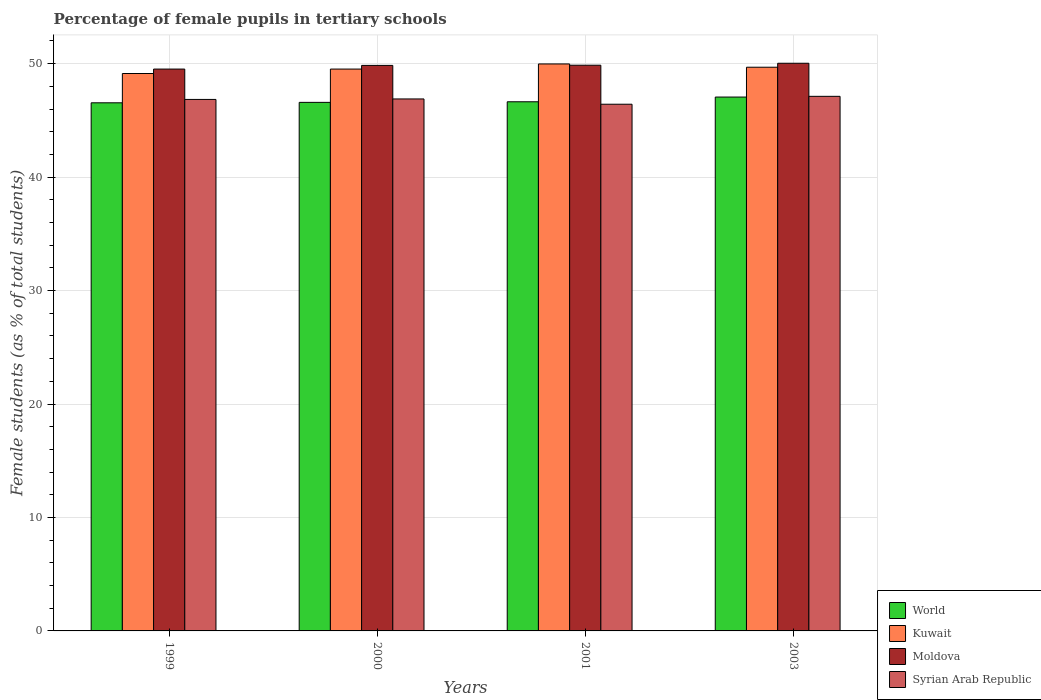How many different coloured bars are there?
Your answer should be very brief. 4. How many groups of bars are there?
Provide a short and direct response. 4. Are the number of bars per tick equal to the number of legend labels?
Give a very brief answer. Yes. What is the percentage of female pupils in tertiary schools in World in 2001?
Your answer should be very brief. 46.64. Across all years, what is the maximum percentage of female pupils in tertiary schools in Syrian Arab Republic?
Provide a succinct answer. 47.12. Across all years, what is the minimum percentage of female pupils in tertiary schools in Moldova?
Provide a short and direct response. 49.52. In which year was the percentage of female pupils in tertiary schools in Syrian Arab Republic minimum?
Provide a short and direct response. 2001. What is the total percentage of female pupils in tertiary schools in Syrian Arab Republic in the graph?
Make the answer very short. 187.27. What is the difference between the percentage of female pupils in tertiary schools in Syrian Arab Republic in 1999 and that in 2001?
Offer a terse response. 0.42. What is the difference between the percentage of female pupils in tertiary schools in Moldova in 2000 and the percentage of female pupils in tertiary schools in Syrian Arab Republic in 2003?
Keep it short and to the point. 2.73. What is the average percentage of female pupils in tertiary schools in Syrian Arab Republic per year?
Provide a succinct answer. 46.82. In the year 2000, what is the difference between the percentage of female pupils in tertiary schools in Syrian Arab Republic and percentage of female pupils in tertiary schools in Moldova?
Ensure brevity in your answer.  -2.96. In how many years, is the percentage of female pupils in tertiary schools in World greater than 34 %?
Give a very brief answer. 4. What is the ratio of the percentage of female pupils in tertiary schools in Syrian Arab Republic in 1999 to that in 2003?
Your response must be concise. 0.99. Is the percentage of female pupils in tertiary schools in Moldova in 2000 less than that in 2003?
Your response must be concise. Yes. Is the difference between the percentage of female pupils in tertiary schools in Syrian Arab Republic in 2000 and 2001 greater than the difference between the percentage of female pupils in tertiary schools in Moldova in 2000 and 2001?
Offer a terse response. Yes. What is the difference between the highest and the second highest percentage of female pupils in tertiary schools in World?
Your answer should be very brief. 0.42. What is the difference between the highest and the lowest percentage of female pupils in tertiary schools in Syrian Arab Republic?
Offer a terse response. 0.7. In how many years, is the percentage of female pupils in tertiary schools in Moldova greater than the average percentage of female pupils in tertiary schools in Moldova taken over all years?
Offer a terse response. 3. What does the 3rd bar from the left in 1999 represents?
Your answer should be compact. Moldova. What does the 3rd bar from the right in 2000 represents?
Offer a very short reply. Kuwait. Is it the case that in every year, the sum of the percentage of female pupils in tertiary schools in Kuwait and percentage of female pupils in tertiary schools in Moldova is greater than the percentage of female pupils in tertiary schools in Syrian Arab Republic?
Provide a short and direct response. Yes. Are all the bars in the graph horizontal?
Give a very brief answer. No. What is the difference between two consecutive major ticks on the Y-axis?
Keep it short and to the point. 10. Are the values on the major ticks of Y-axis written in scientific E-notation?
Provide a succinct answer. No. Does the graph contain any zero values?
Provide a short and direct response. No. Does the graph contain grids?
Provide a short and direct response. Yes. Where does the legend appear in the graph?
Provide a succinct answer. Bottom right. How are the legend labels stacked?
Provide a short and direct response. Vertical. What is the title of the graph?
Your response must be concise. Percentage of female pupils in tertiary schools. Does "Aruba" appear as one of the legend labels in the graph?
Give a very brief answer. No. What is the label or title of the X-axis?
Provide a short and direct response. Years. What is the label or title of the Y-axis?
Your response must be concise. Female students (as % of total students). What is the Female students (as % of total students) of World in 1999?
Keep it short and to the point. 46.55. What is the Female students (as % of total students) of Kuwait in 1999?
Your answer should be compact. 49.13. What is the Female students (as % of total students) in Moldova in 1999?
Your response must be concise. 49.52. What is the Female students (as % of total students) of Syrian Arab Republic in 1999?
Provide a succinct answer. 46.84. What is the Female students (as % of total students) of World in 2000?
Give a very brief answer. 46.59. What is the Female students (as % of total students) in Kuwait in 2000?
Provide a succinct answer. 49.52. What is the Female students (as % of total students) of Moldova in 2000?
Your response must be concise. 49.84. What is the Female students (as % of total students) of Syrian Arab Republic in 2000?
Your response must be concise. 46.89. What is the Female students (as % of total students) in World in 2001?
Your answer should be very brief. 46.64. What is the Female students (as % of total students) of Kuwait in 2001?
Provide a succinct answer. 49.97. What is the Female students (as % of total students) in Moldova in 2001?
Keep it short and to the point. 49.86. What is the Female students (as % of total students) of Syrian Arab Republic in 2001?
Your answer should be compact. 46.42. What is the Female students (as % of total students) of World in 2003?
Make the answer very short. 47.05. What is the Female students (as % of total students) of Kuwait in 2003?
Ensure brevity in your answer.  49.68. What is the Female students (as % of total students) of Moldova in 2003?
Keep it short and to the point. 50.03. What is the Female students (as % of total students) in Syrian Arab Republic in 2003?
Provide a succinct answer. 47.12. Across all years, what is the maximum Female students (as % of total students) of World?
Offer a terse response. 47.05. Across all years, what is the maximum Female students (as % of total students) of Kuwait?
Keep it short and to the point. 49.97. Across all years, what is the maximum Female students (as % of total students) of Moldova?
Your response must be concise. 50.03. Across all years, what is the maximum Female students (as % of total students) in Syrian Arab Republic?
Ensure brevity in your answer.  47.12. Across all years, what is the minimum Female students (as % of total students) in World?
Provide a succinct answer. 46.55. Across all years, what is the minimum Female students (as % of total students) of Kuwait?
Your answer should be very brief. 49.13. Across all years, what is the minimum Female students (as % of total students) of Moldova?
Provide a short and direct response. 49.52. Across all years, what is the minimum Female students (as % of total students) in Syrian Arab Republic?
Ensure brevity in your answer.  46.42. What is the total Female students (as % of total students) in World in the graph?
Provide a succinct answer. 186.82. What is the total Female students (as % of total students) in Kuwait in the graph?
Offer a terse response. 198.31. What is the total Female students (as % of total students) in Moldova in the graph?
Your answer should be compact. 199.26. What is the total Female students (as % of total students) of Syrian Arab Republic in the graph?
Your response must be concise. 187.27. What is the difference between the Female students (as % of total students) of World in 1999 and that in 2000?
Make the answer very short. -0.04. What is the difference between the Female students (as % of total students) of Kuwait in 1999 and that in 2000?
Provide a succinct answer. -0.39. What is the difference between the Female students (as % of total students) of Moldova in 1999 and that in 2000?
Provide a succinct answer. -0.32. What is the difference between the Female students (as % of total students) in Syrian Arab Republic in 1999 and that in 2000?
Provide a short and direct response. -0.04. What is the difference between the Female students (as % of total students) of World in 1999 and that in 2001?
Offer a terse response. -0.09. What is the difference between the Female students (as % of total students) of Kuwait in 1999 and that in 2001?
Your answer should be compact. -0.84. What is the difference between the Female students (as % of total students) of Moldova in 1999 and that in 2001?
Provide a succinct answer. -0.34. What is the difference between the Female students (as % of total students) of Syrian Arab Republic in 1999 and that in 2001?
Offer a terse response. 0.42. What is the difference between the Female students (as % of total students) of World in 1999 and that in 2003?
Offer a very short reply. -0.51. What is the difference between the Female students (as % of total students) of Kuwait in 1999 and that in 2003?
Your answer should be very brief. -0.55. What is the difference between the Female students (as % of total students) in Moldova in 1999 and that in 2003?
Make the answer very short. -0.51. What is the difference between the Female students (as % of total students) of Syrian Arab Republic in 1999 and that in 2003?
Offer a very short reply. -0.27. What is the difference between the Female students (as % of total students) of World in 2000 and that in 2001?
Ensure brevity in your answer.  -0.05. What is the difference between the Female students (as % of total students) in Kuwait in 2000 and that in 2001?
Your answer should be very brief. -0.45. What is the difference between the Female students (as % of total students) of Moldova in 2000 and that in 2001?
Offer a terse response. -0.02. What is the difference between the Female students (as % of total students) of Syrian Arab Republic in 2000 and that in 2001?
Offer a very short reply. 0.47. What is the difference between the Female students (as % of total students) of World in 2000 and that in 2003?
Offer a terse response. -0.47. What is the difference between the Female students (as % of total students) of Kuwait in 2000 and that in 2003?
Give a very brief answer. -0.16. What is the difference between the Female students (as % of total students) in Moldova in 2000 and that in 2003?
Keep it short and to the point. -0.19. What is the difference between the Female students (as % of total students) in Syrian Arab Republic in 2000 and that in 2003?
Your response must be concise. -0.23. What is the difference between the Female students (as % of total students) in World in 2001 and that in 2003?
Your answer should be compact. -0.42. What is the difference between the Female students (as % of total students) of Kuwait in 2001 and that in 2003?
Offer a terse response. 0.29. What is the difference between the Female students (as % of total students) in Moldova in 2001 and that in 2003?
Make the answer very short. -0.17. What is the difference between the Female students (as % of total students) in Syrian Arab Republic in 2001 and that in 2003?
Your answer should be very brief. -0.7. What is the difference between the Female students (as % of total students) in World in 1999 and the Female students (as % of total students) in Kuwait in 2000?
Give a very brief answer. -2.97. What is the difference between the Female students (as % of total students) of World in 1999 and the Female students (as % of total students) of Moldova in 2000?
Offer a terse response. -3.3. What is the difference between the Female students (as % of total students) of World in 1999 and the Female students (as % of total students) of Syrian Arab Republic in 2000?
Offer a terse response. -0.34. What is the difference between the Female students (as % of total students) of Kuwait in 1999 and the Female students (as % of total students) of Moldova in 2000?
Your answer should be very brief. -0.71. What is the difference between the Female students (as % of total students) in Kuwait in 1999 and the Female students (as % of total students) in Syrian Arab Republic in 2000?
Ensure brevity in your answer.  2.24. What is the difference between the Female students (as % of total students) of Moldova in 1999 and the Female students (as % of total students) of Syrian Arab Republic in 2000?
Provide a short and direct response. 2.63. What is the difference between the Female students (as % of total students) of World in 1999 and the Female students (as % of total students) of Kuwait in 2001?
Provide a short and direct response. -3.43. What is the difference between the Female students (as % of total students) of World in 1999 and the Female students (as % of total students) of Moldova in 2001?
Your response must be concise. -3.31. What is the difference between the Female students (as % of total students) in World in 1999 and the Female students (as % of total students) in Syrian Arab Republic in 2001?
Give a very brief answer. 0.13. What is the difference between the Female students (as % of total students) of Kuwait in 1999 and the Female students (as % of total students) of Moldova in 2001?
Make the answer very short. -0.73. What is the difference between the Female students (as % of total students) of Kuwait in 1999 and the Female students (as % of total students) of Syrian Arab Republic in 2001?
Your answer should be compact. 2.71. What is the difference between the Female students (as % of total students) in Moldova in 1999 and the Female students (as % of total students) in Syrian Arab Republic in 2001?
Give a very brief answer. 3.1. What is the difference between the Female students (as % of total students) in World in 1999 and the Female students (as % of total students) in Kuwait in 2003?
Your answer should be compact. -3.14. What is the difference between the Female students (as % of total students) in World in 1999 and the Female students (as % of total students) in Moldova in 2003?
Ensure brevity in your answer.  -3.49. What is the difference between the Female students (as % of total students) of World in 1999 and the Female students (as % of total students) of Syrian Arab Republic in 2003?
Your response must be concise. -0.57. What is the difference between the Female students (as % of total students) of Kuwait in 1999 and the Female students (as % of total students) of Moldova in 2003?
Keep it short and to the point. -0.9. What is the difference between the Female students (as % of total students) of Kuwait in 1999 and the Female students (as % of total students) of Syrian Arab Republic in 2003?
Your answer should be compact. 2.01. What is the difference between the Female students (as % of total students) of Moldova in 1999 and the Female students (as % of total students) of Syrian Arab Republic in 2003?
Keep it short and to the point. 2.4. What is the difference between the Female students (as % of total students) of World in 2000 and the Female students (as % of total students) of Kuwait in 2001?
Provide a succinct answer. -3.39. What is the difference between the Female students (as % of total students) of World in 2000 and the Female students (as % of total students) of Moldova in 2001?
Provide a short and direct response. -3.27. What is the difference between the Female students (as % of total students) in World in 2000 and the Female students (as % of total students) in Syrian Arab Republic in 2001?
Your answer should be compact. 0.16. What is the difference between the Female students (as % of total students) of Kuwait in 2000 and the Female students (as % of total students) of Moldova in 2001?
Provide a short and direct response. -0.34. What is the difference between the Female students (as % of total students) of Kuwait in 2000 and the Female students (as % of total students) of Syrian Arab Republic in 2001?
Give a very brief answer. 3.1. What is the difference between the Female students (as % of total students) of Moldova in 2000 and the Female students (as % of total students) of Syrian Arab Republic in 2001?
Your answer should be compact. 3.42. What is the difference between the Female students (as % of total students) of World in 2000 and the Female students (as % of total students) of Kuwait in 2003?
Ensure brevity in your answer.  -3.1. What is the difference between the Female students (as % of total students) of World in 2000 and the Female students (as % of total students) of Moldova in 2003?
Your answer should be compact. -3.45. What is the difference between the Female students (as % of total students) in World in 2000 and the Female students (as % of total students) in Syrian Arab Republic in 2003?
Provide a short and direct response. -0.53. What is the difference between the Female students (as % of total students) in Kuwait in 2000 and the Female students (as % of total students) in Moldova in 2003?
Offer a terse response. -0.51. What is the difference between the Female students (as % of total students) of Kuwait in 2000 and the Female students (as % of total students) of Syrian Arab Republic in 2003?
Give a very brief answer. 2.4. What is the difference between the Female students (as % of total students) of Moldova in 2000 and the Female students (as % of total students) of Syrian Arab Republic in 2003?
Make the answer very short. 2.73. What is the difference between the Female students (as % of total students) in World in 2001 and the Female students (as % of total students) in Kuwait in 2003?
Keep it short and to the point. -3.04. What is the difference between the Female students (as % of total students) in World in 2001 and the Female students (as % of total students) in Moldova in 2003?
Provide a succinct answer. -3.39. What is the difference between the Female students (as % of total students) of World in 2001 and the Female students (as % of total students) of Syrian Arab Republic in 2003?
Keep it short and to the point. -0.48. What is the difference between the Female students (as % of total students) of Kuwait in 2001 and the Female students (as % of total students) of Moldova in 2003?
Give a very brief answer. -0.06. What is the difference between the Female students (as % of total students) of Kuwait in 2001 and the Female students (as % of total students) of Syrian Arab Republic in 2003?
Give a very brief answer. 2.86. What is the difference between the Female students (as % of total students) in Moldova in 2001 and the Female students (as % of total students) in Syrian Arab Republic in 2003?
Your answer should be very brief. 2.74. What is the average Female students (as % of total students) in World per year?
Keep it short and to the point. 46.71. What is the average Female students (as % of total students) of Kuwait per year?
Provide a short and direct response. 49.58. What is the average Female students (as % of total students) in Moldova per year?
Offer a very short reply. 49.81. What is the average Female students (as % of total students) of Syrian Arab Republic per year?
Provide a succinct answer. 46.82. In the year 1999, what is the difference between the Female students (as % of total students) in World and Female students (as % of total students) in Kuwait?
Provide a succinct answer. -2.58. In the year 1999, what is the difference between the Female students (as % of total students) in World and Female students (as % of total students) in Moldova?
Your answer should be compact. -2.97. In the year 1999, what is the difference between the Female students (as % of total students) of World and Female students (as % of total students) of Syrian Arab Republic?
Ensure brevity in your answer.  -0.3. In the year 1999, what is the difference between the Female students (as % of total students) of Kuwait and Female students (as % of total students) of Moldova?
Provide a short and direct response. -0.39. In the year 1999, what is the difference between the Female students (as % of total students) of Kuwait and Female students (as % of total students) of Syrian Arab Republic?
Offer a very short reply. 2.29. In the year 1999, what is the difference between the Female students (as % of total students) in Moldova and Female students (as % of total students) in Syrian Arab Republic?
Keep it short and to the point. 2.68. In the year 2000, what is the difference between the Female students (as % of total students) in World and Female students (as % of total students) in Kuwait?
Offer a terse response. -2.94. In the year 2000, what is the difference between the Female students (as % of total students) of World and Female students (as % of total students) of Moldova?
Ensure brevity in your answer.  -3.26. In the year 2000, what is the difference between the Female students (as % of total students) in World and Female students (as % of total students) in Syrian Arab Republic?
Give a very brief answer. -0.3. In the year 2000, what is the difference between the Female students (as % of total students) in Kuwait and Female students (as % of total students) in Moldova?
Your response must be concise. -0.32. In the year 2000, what is the difference between the Female students (as % of total students) of Kuwait and Female students (as % of total students) of Syrian Arab Republic?
Your response must be concise. 2.63. In the year 2000, what is the difference between the Female students (as % of total students) of Moldova and Female students (as % of total students) of Syrian Arab Republic?
Provide a short and direct response. 2.96. In the year 2001, what is the difference between the Female students (as % of total students) of World and Female students (as % of total students) of Kuwait?
Your answer should be very brief. -3.33. In the year 2001, what is the difference between the Female students (as % of total students) of World and Female students (as % of total students) of Moldova?
Make the answer very short. -3.22. In the year 2001, what is the difference between the Female students (as % of total students) in World and Female students (as % of total students) in Syrian Arab Republic?
Provide a succinct answer. 0.22. In the year 2001, what is the difference between the Female students (as % of total students) of Kuwait and Female students (as % of total students) of Moldova?
Offer a terse response. 0.11. In the year 2001, what is the difference between the Female students (as % of total students) of Kuwait and Female students (as % of total students) of Syrian Arab Republic?
Give a very brief answer. 3.55. In the year 2001, what is the difference between the Female students (as % of total students) in Moldova and Female students (as % of total students) in Syrian Arab Republic?
Provide a short and direct response. 3.44. In the year 2003, what is the difference between the Female students (as % of total students) in World and Female students (as % of total students) in Kuwait?
Provide a short and direct response. -2.63. In the year 2003, what is the difference between the Female students (as % of total students) in World and Female students (as % of total students) in Moldova?
Provide a short and direct response. -2.98. In the year 2003, what is the difference between the Female students (as % of total students) of World and Female students (as % of total students) of Syrian Arab Republic?
Your answer should be very brief. -0.06. In the year 2003, what is the difference between the Female students (as % of total students) in Kuwait and Female students (as % of total students) in Moldova?
Your response must be concise. -0.35. In the year 2003, what is the difference between the Female students (as % of total students) in Kuwait and Female students (as % of total students) in Syrian Arab Republic?
Keep it short and to the point. 2.57. In the year 2003, what is the difference between the Female students (as % of total students) of Moldova and Female students (as % of total students) of Syrian Arab Republic?
Make the answer very short. 2.92. What is the ratio of the Female students (as % of total students) of World in 1999 to that in 2000?
Provide a short and direct response. 1. What is the ratio of the Female students (as % of total students) of Syrian Arab Republic in 1999 to that in 2000?
Provide a succinct answer. 1. What is the ratio of the Female students (as % of total students) of World in 1999 to that in 2001?
Provide a short and direct response. 1. What is the ratio of the Female students (as % of total students) in Kuwait in 1999 to that in 2001?
Your response must be concise. 0.98. What is the ratio of the Female students (as % of total students) of Moldova in 1999 to that in 2001?
Give a very brief answer. 0.99. What is the ratio of the Female students (as % of total students) of Syrian Arab Republic in 1999 to that in 2001?
Offer a very short reply. 1.01. What is the ratio of the Female students (as % of total students) of World in 1999 to that in 2003?
Give a very brief answer. 0.99. What is the ratio of the Female students (as % of total students) of Kuwait in 1999 to that in 2003?
Give a very brief answer. 0.99. What is the ratio of the Female students (as % of total students) of Moldova in 1999 to that in 2003?
Ensure brevity in your answer.  0.99. What is the ratio of the Female students (as % of total students) in Kuwait in 2000 to that in 2001?
Your answer should be compact. 0.99. What is the ratio of the Female students (as % of total students) in Moldova in 2000 to that in 2001?
Give a very brief answer. 1. What is the ratio of the Female students (as % of total students) in World in 2000 to that in 2003?
Provide a short and direct response. 0.99. What is the ratio of the Female students (as % of total students) in Kuwait in 2000 to that in 2003?
Give a very brief answer. 1. What is the ratio of the Female students (as % of total students) in Syrian Arab Republic in 2000 to that in 2003?
Give a very brief answer. 1. What is the ratio of the Female students (as % of total students) of Moldova in 2001 to that in 2003?
Offer a terse response. 1. What is the ratio of the Female students (as % of total students) in Syrian Arab Republic in 2001 to that in 2003?
Ensure brevity in your answer.  0.99. What is the difference between the highest and the second highest Female students (as % of total students) of World?
Offer a very short reply. 0.42. What is the difference between the highest and the second highest Female students (as % of total students) in Kuwait?
Keep it short and to the point. 0.29. What is the difference between the highest and the second highest Female students (as % of total students) of Moldova?
Your response must be concise. 0.17. What is the difference between the highest and the second highest Female students (as % of total students) in Syrian Arab Republic?
Offer a very short reply. 0.23. What is the difference between the highest and the lowest Female students (as % of total students) of World?
Provide a short and direct response. 0.51. What is the difference between the highest and the lowest Female students (as % of total students) in Kuwait?
Provide a succinct answer. 0.84. What is the difference between the highest and the lowest Female students (as % of total students) of Moldova?
Provide a short and direct response. 0.51. What is the difference between the highest and the lowest Female students (as % of total students) in Syrian Arab Republic?
Your response must be concise. 0.7. 